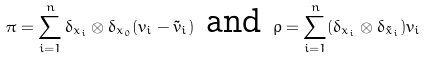<formula> <loc_0><loc_0><loc_500><loc_500>\pi = \sum _ { i = 1 } ^ { n } \delta _ { x _ { i } } \otimes \delta _ { x _ { 0 } } ( v _ { i } - \tilde { v } _ { i } ) \text { and } \rho = \sum _ { i = 1 } ^ { n } ( \delta _ { x _ { i } } \otimes \delta _ { \tilde { x } _ { i } } ) v _ { i }</formula> 